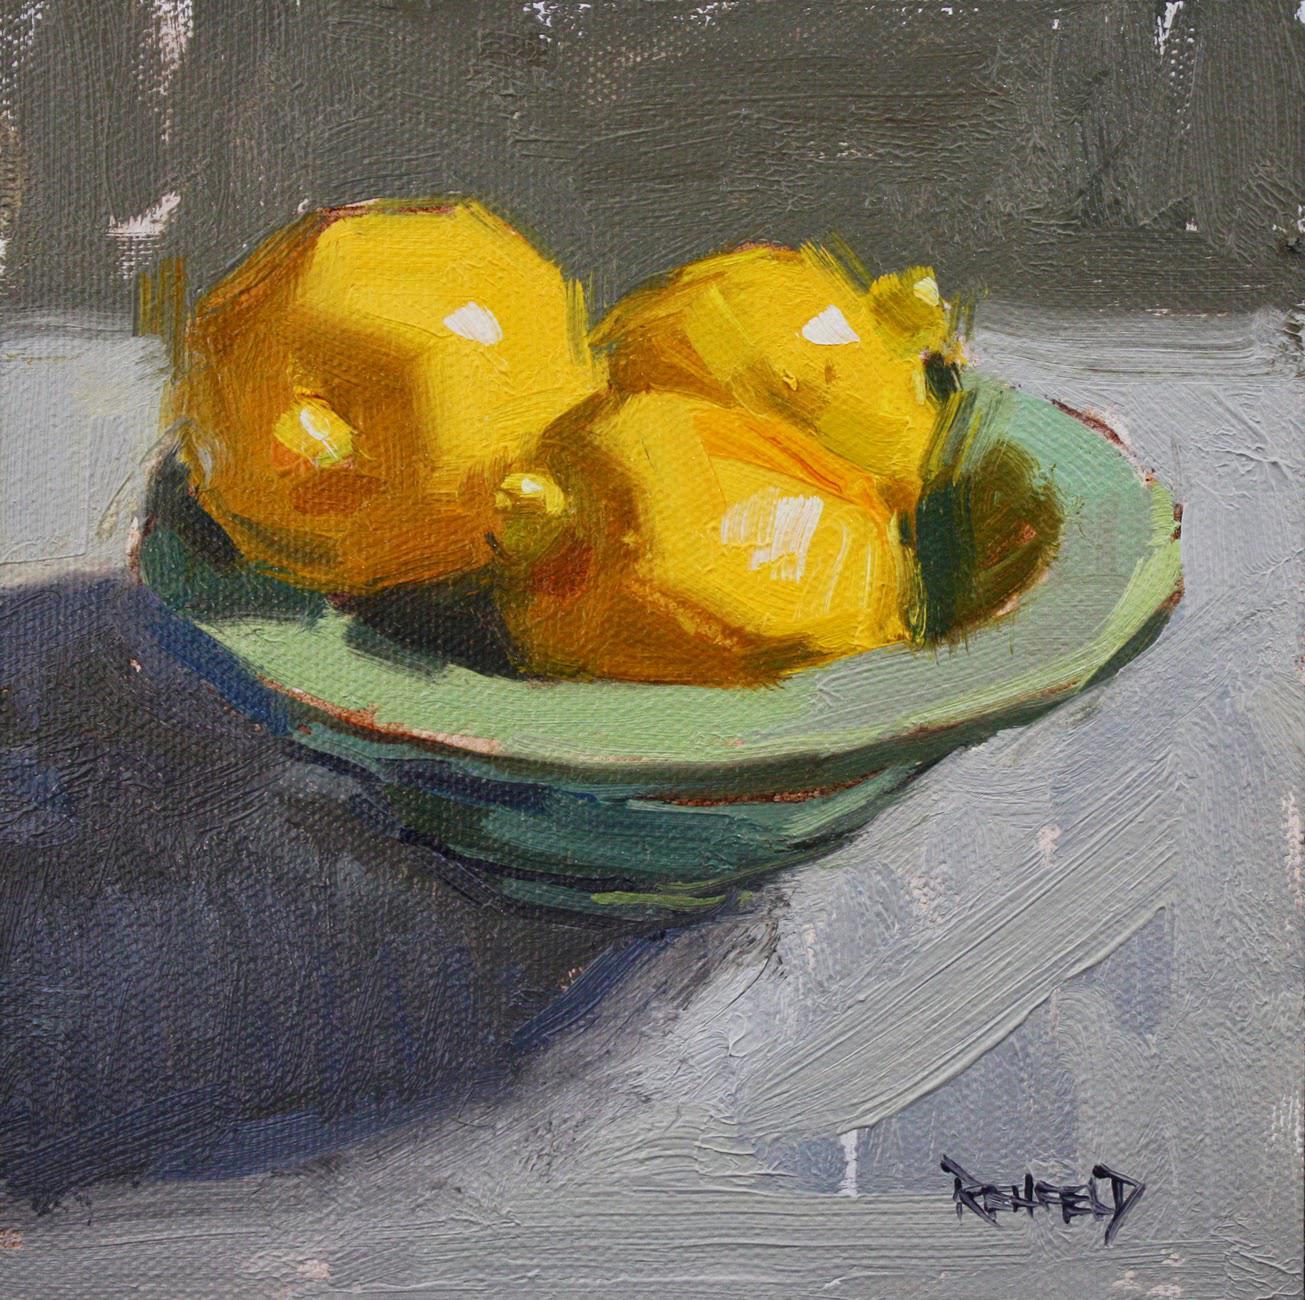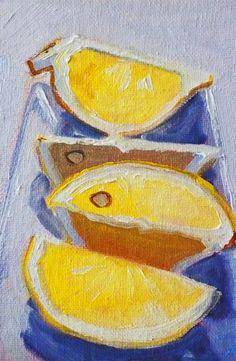The first image is the image on the left, the second image is the image on the right. For the images shown, is this caption "The artwork of one image shows three whole lemons arranged in a bowl, while a second artwork image is of lemon wedges in blue shadows." true? Answer yes or no. Yes. 